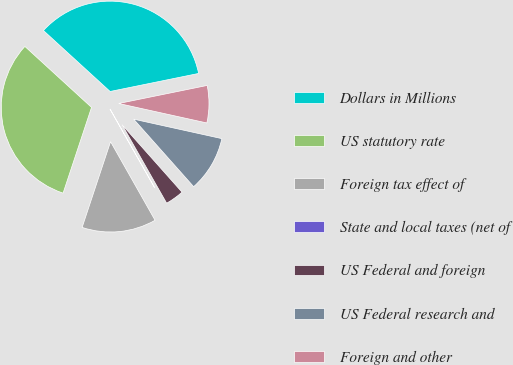Convert chart to OTSL. <chart><loc_0><loc_0><loc_500><loc_500><pie_chart><fcel>Dollars in Millions<fcel>US statutory rate<fcel>Foreign tax effect of<fcel>State and local taxes (net of<fcel>US Federal and foreign<fcel>US Federal research and<fcel>Foreign and other<nl><fcel>35.01%<fcel>31.69%<fcel>13.3%<fcel>0.02%<fcel>3.34%<fcel>9.98%<fcel>6.66%<nl></chart> 